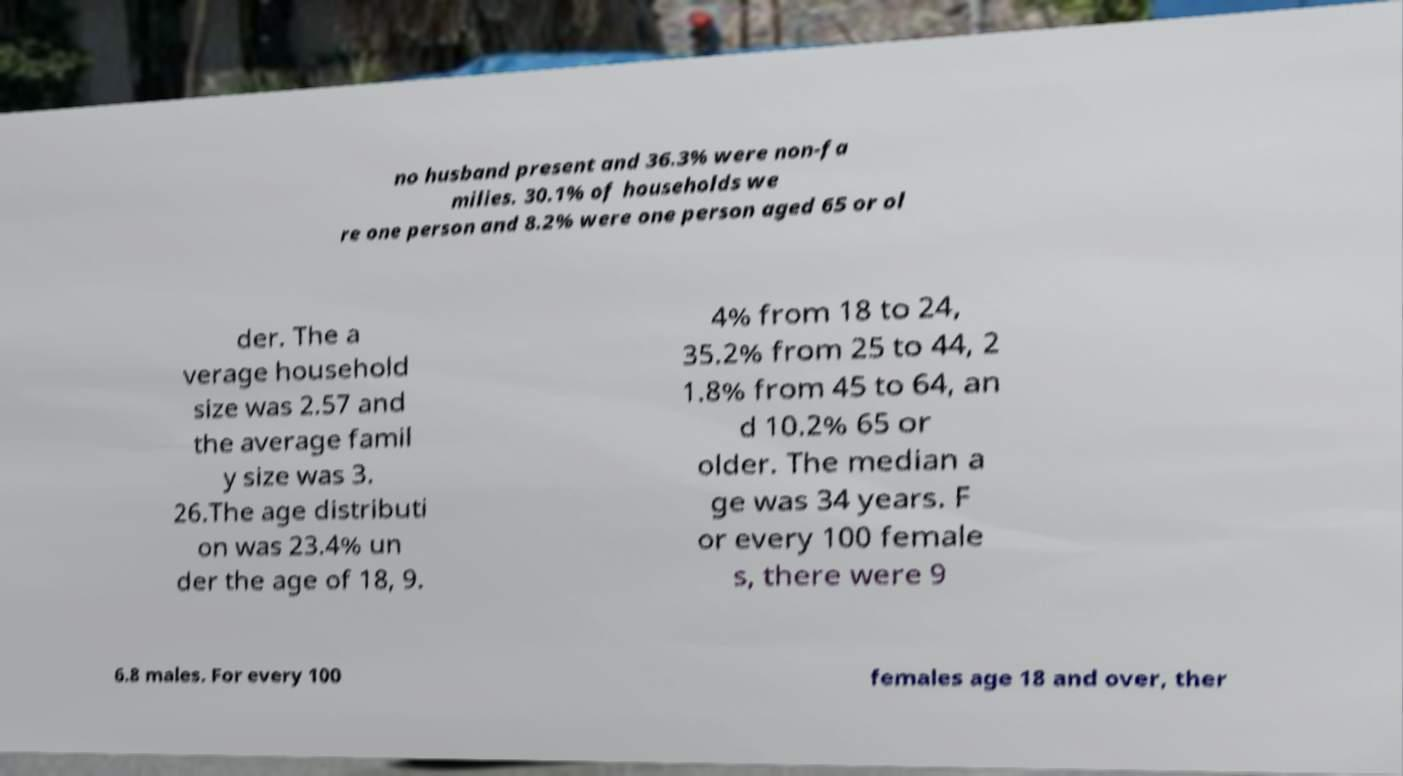Could you extract and type out the text from this image? no husband present and 36.3% were non-fa milies. 30.1% of households we re one person and 8.2% were one person aged 65 or ol der. The a verage household size was 2.57 and the average famil y size was 3. 26.The age distributi on was 23.4% un der the age of 18, 9. 4% from 18 to 24, 35.2% from 25 to 44, 2 1.8% from 45 to 64, an d 10.2% 65 or older. The median a ge was 34 years. F or every 100 female s, there were 9 6.8 males. For every 100 females age 18 and over, ther 